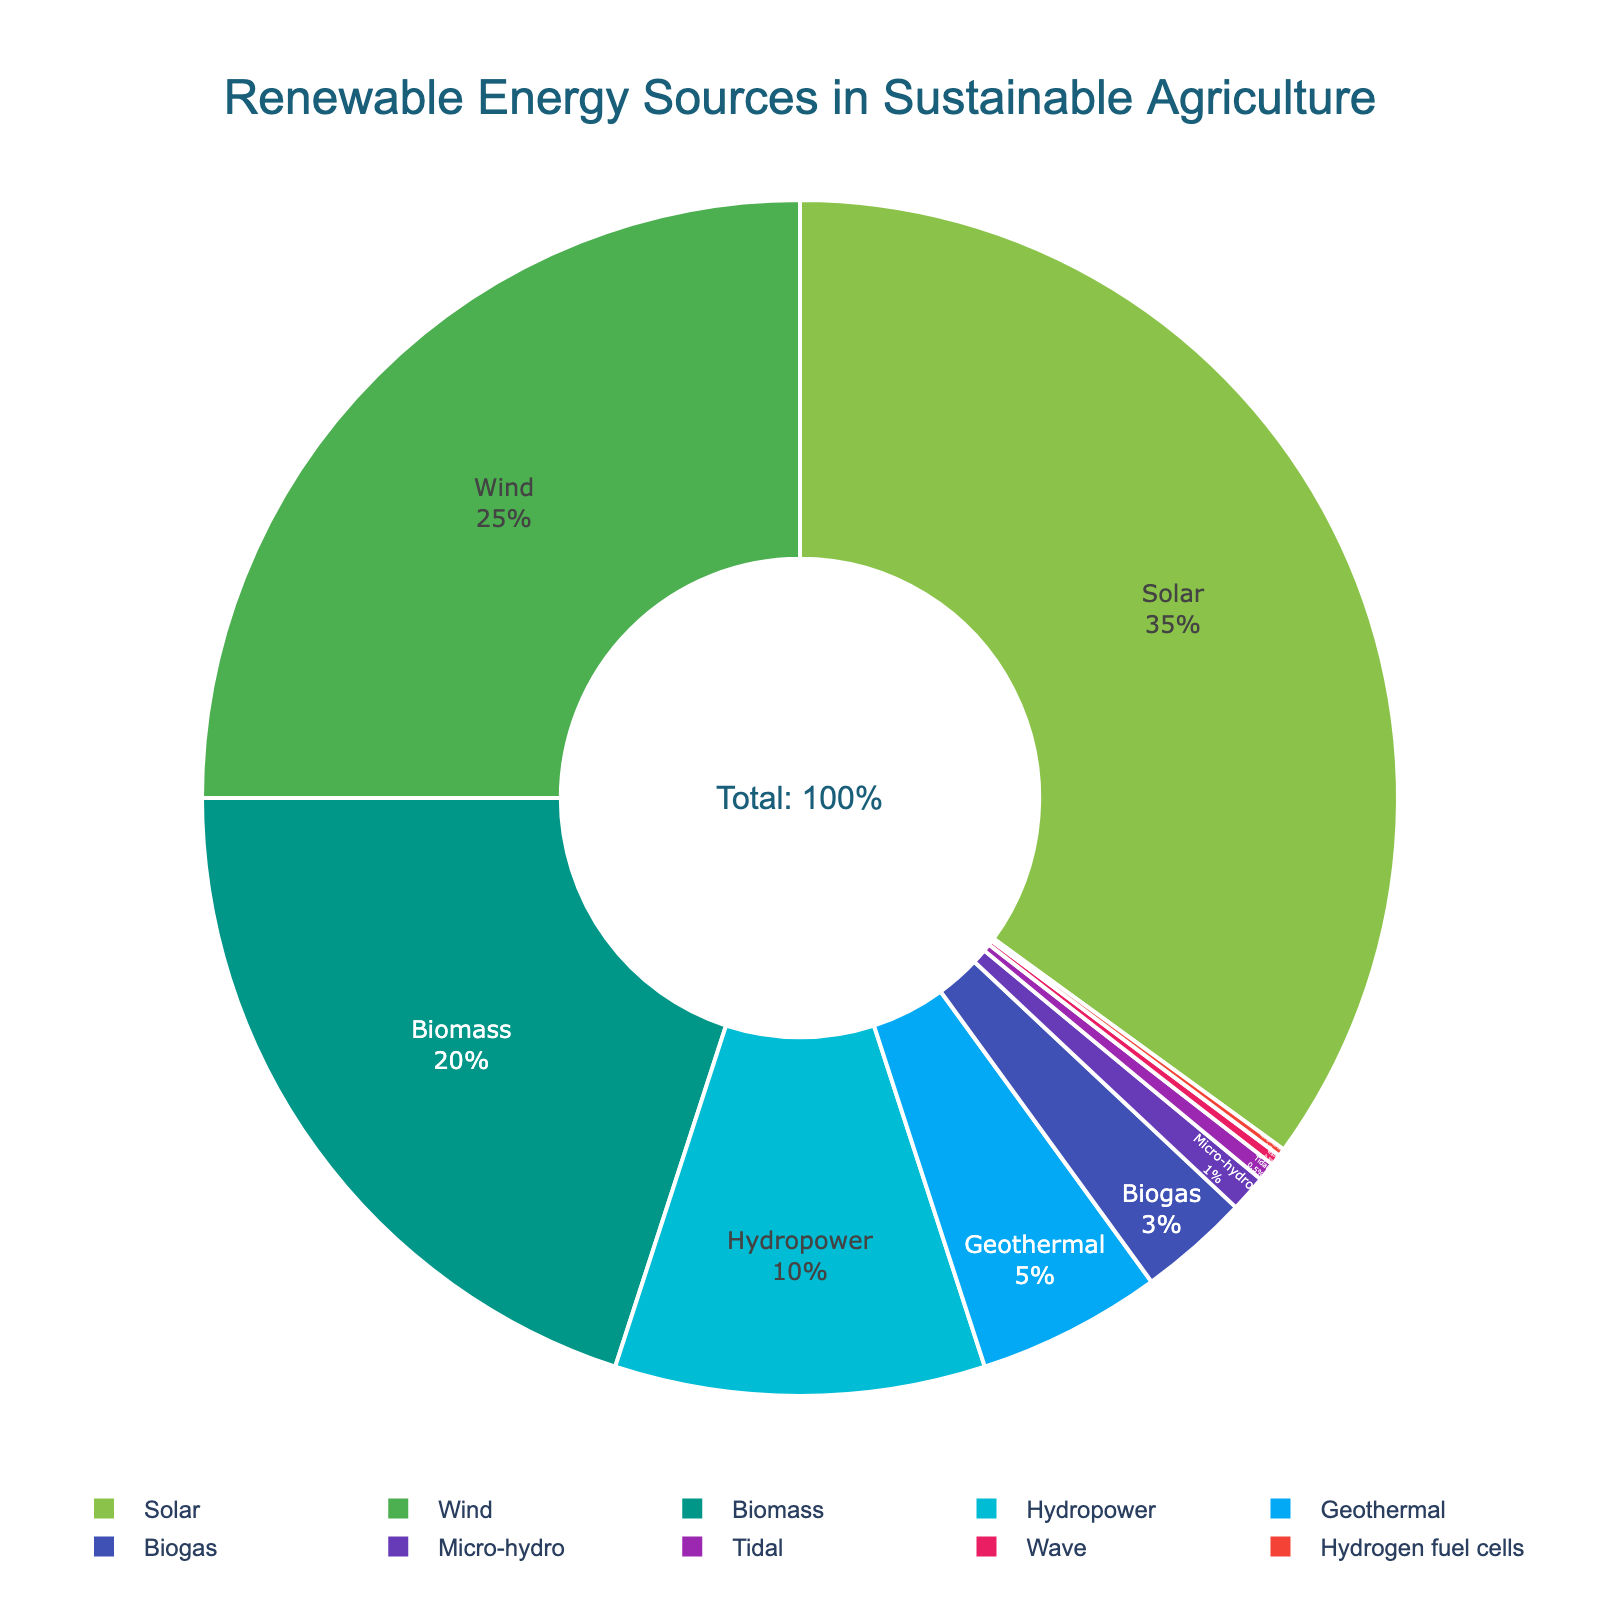What's the largest source of renewable energy used in sustainable agriculture? Look at the pie chart and identify the segment with the largest percentage. The segment labeled "Solar" has the largest share at 35%.
Answer: Solar How much more percentage does wind energy contribute compared to biogas? Wind energy is 25%, while biogas is 3%. Subtract the percentage of biogas from wind energy: 25% - 3% = 22%.
Answer: 22% Which energy sources combined make up exactly half of the renewable energy used? Add the percentages of the largest sources until reaching half of the total (50%). Solar (35%) + Wind (25%) = 60%. Skip wind energy and recalculate. Solar (35%) + Biomass (20%) = 55%, which is too much. Only Solar accounts for more than half of 50% at 35%, so none exactly sum up to 50%.
Answer: None What is the combined percentage of Hydropower, Geothermal, and Biogas? Add the percentages of Hydropower (10%), Geothermal (5%), and Biogas (3%). 10% + 5% + 3% = 18%.
Answer: 18% Which source has the least contribution to sustainable agriculture energy and what is its percentage? Look at the pie chart and identify the segment with the smallest percentage. The smallest section is labeled "Hydrogen fuel cells" and has a percentage of 0.2%.
Answer: Hydrogen fuel cells, 0.2% Is the contribution of Biomass and Wind energy combined greater than that of Solar energy? Add the percentages of Biomass (20%) and Wind energy (25%). Compare the sum with Solar's percentage. 20% + 25% = 45%, which is greater than Solar's 35%.
Answer: Yes What color represents the Biomass energy source? Look at the pie chart and identify the color associated with "Biomass". Biomass is shown in green (#009688).
Answer: Green How many sources of renewable energy contribute 10% or less each? Count the segments on the pie chart labeled with percentages of 10% or less. Hydropower (10%), Geothermal (5%), Biogas (3%), Micro-hydro (1%), Tidal (0.5%), Wave (0.3%), Hydrogen fuel cells (0.2%) = 7 sources.
Answer: 7 What's the difference in percentage between the most and the least used renewable energy sources? Subtract the smallest percentage from the largest percentage. Solar (35%) minus Hydrogen fuel cells (0.2%) results in 34.8%.
Answer: 34.8% Which energy sources combined make up less than 5% of the total and what is their total contribution? Sum the percentages of the smallest segments until reaching less than 5%. Tidal (0.5%) + Wave (0.3%) + Hydrogen fuel cells (0.2%) = 1%. This is the combined contribution.
Answer: Tidal, Wave, Hydrogen fuel cells. Total: 1% 